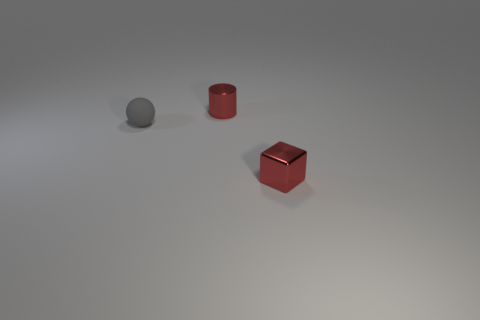Can you describe the texture differences between the three objects in the image? The sphere has a smooth, uniform texture, appearing to have a matte finish. The cylinder has a slight reflective quality with a smooth surface, indicating a metallic or polished finish. The cube appears to have a reflective, perhaps even glossy surface, suggesting a different material, possibly acrylic or metal. 